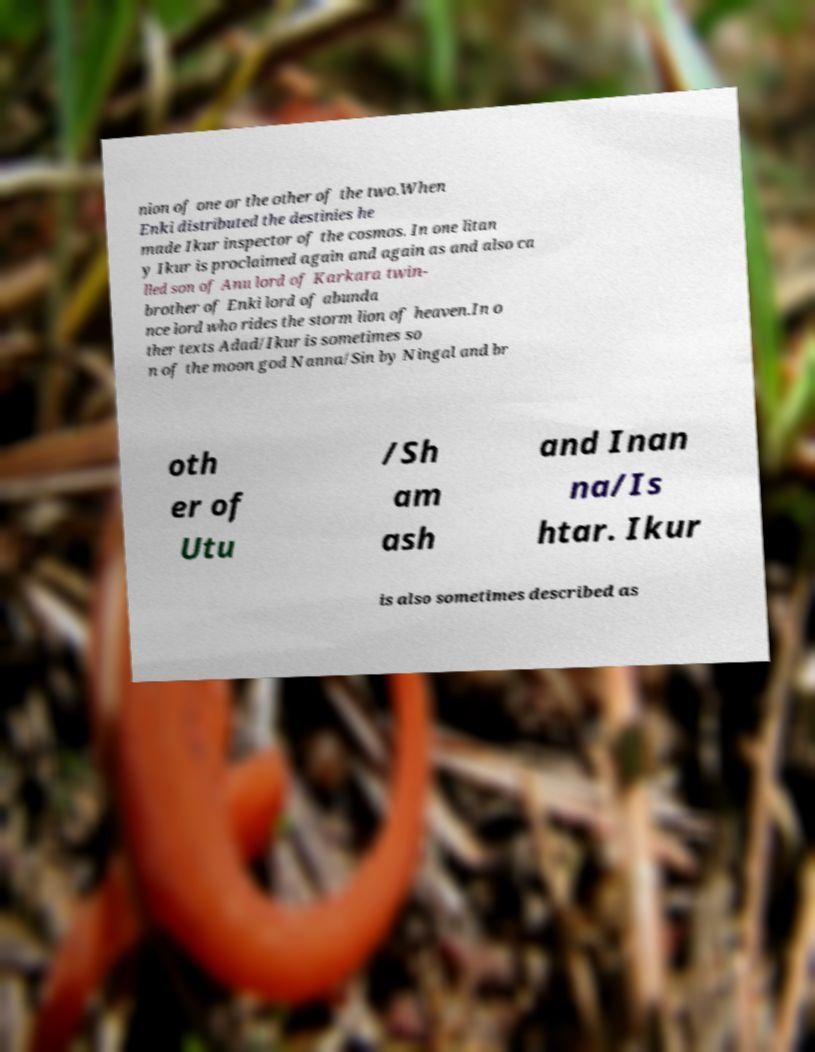Please identify and transcribe the text found in this image. nion of one or the other of the two.When Enki distributed the destinies he made Ikur inspector of the cosmos. In one litan y Ikur is proclaimed again and again as and also ca lled son of Anu lord of Karkara twin- brother of Enki lord of abunda nce lord who rides the storm lion of heaven.In o ther texts Adad/Ikur is sometimes so n of the moon god Nanna/Sin by Ningal and br oth er of Utu /Sh am ash and Inan na/Is htar. Ikur is also sometimes described as 